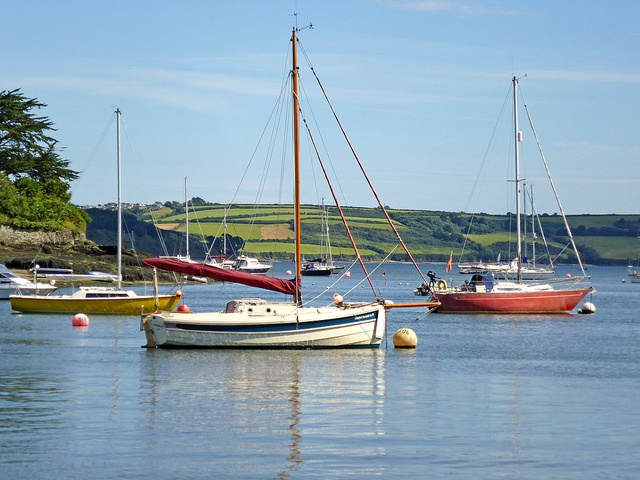Describe the objects in this image and their specific colors. I can see boat in lightblue, ivory, gray, black, and tan tones, boat in lightblue, olive, black, and gray tones, boat in lightblue, gray, white, and darkgray tones, boat in lightblue, gray, white, and darkgray tones, and boat in lightblue, white, gray, darkgray, and navy tones in this image. 